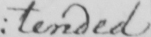What is written in this line of handwriting? : tended 